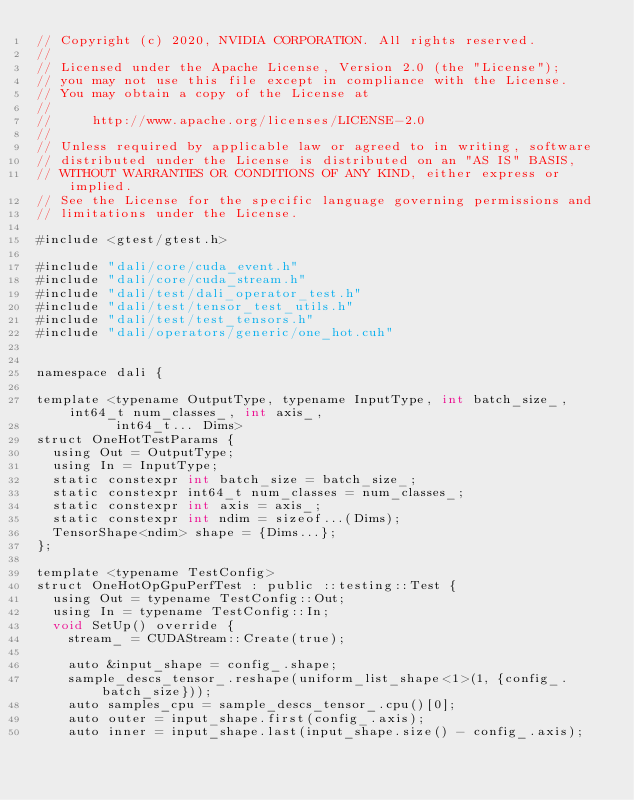<code> <loc_0><loc_0><loc_500><loc_500><_Cuda_>// Copyright (c) 2020, NVIDIA CORPORATION. All rights reserved.
//
// Licensed under the Apache License, Version 2.0 (the "License");
// you may not use this file except in compliance with the License.
// You may obtain a copy of the License at
//
//     http://www.apache.org/licenses/LICENSE-2.0
//
// Unless required by applicable law or agreed to in writing, software
// distributed under the License is distributed on an "AS IS" BASIS,
// WITHOUT WARRANTIES OR CONDITIONS OF ANY KIND, either express or implied.
// See the License for the specific language governing permissions and
// limitations under the License.

#include <gtest/gtest.h>

#include "dali/core/cuda_event.h"
#include "dali/core/cuda_stream.h"
#include "dali/test/dali_operator_test.h"
#include "dali/test/tensor_test_utils.h"
#include "dali/test/test_tensors.h"
#include "dali/operators/generic/one_hot.cuh"


namespace dali {

template <typename OutputType, typename InputType, int batch_size_, int64_t num_classes_, int axis_,
          int64_t... Dims>
struct OneHotTestParams {
  using Out = OutputType;
  using In = InputType;
  static constexpr int batch_size = batch_size_;
  static constexpr int64_t num_classes = num_classes_;
  static constexpr int axis = axis_;
  static constexpr int ndim = sizeof...(Dims);
  TensorShape<ndim> shape = {Dims...};
};

template <typename TestConfig>
struct OneHotOpGpuPerfTest : public ::testing::Test {
  using Out = typename TestConfig::Out;
  using In = typename TestConfig::In;
  void SetUp() override {
    stream_ = CUDAStream::Create(true);

    auto &input_shape = config_.shape;
    sample_descs_tensor_.reshape(uniform_list_shape<1>(1, {config_.batch_size}));
    auto samples_cpu = sample_descs_tensor_.cpu()[0];
    auto outer = input_shape.first(config_.axis);
    auto inner = input_shape.last(input_shape.size() - config_.axis);</code> 